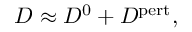Convert formula to latex. <formula><loc_0><loc_0><loc_500><loc_500>\begin{array} { r } { D \approx D ^ { 0 } + D ^ { p e r t } , } \end{array}</formula> 